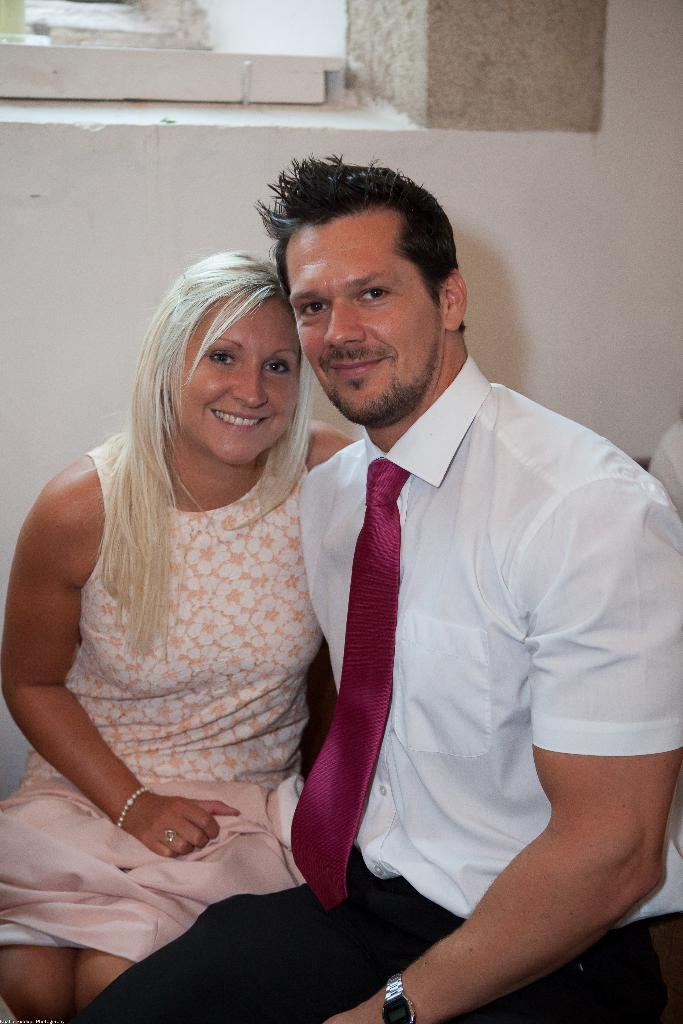Who are the two people in the image? There is a couple in the image. Where is the man positioned in relation to the image? The man is on the right side of the image. What is the man wearing in the image? The man is wearing a white shirt. Where is the woman positioned in relation to the image? The woman is on the left side of the image. What can be seen in the background of the image? There is a wall in the background of the image. What type of apple is the man holding in the image? There is no apple present in the image; the man is wearing a white shirt and standing next to a woman. Can you describe the desk that the couple is sitting at in the image? There is no desk present in the image; the couple is standing next to each other with a wall in the background. 